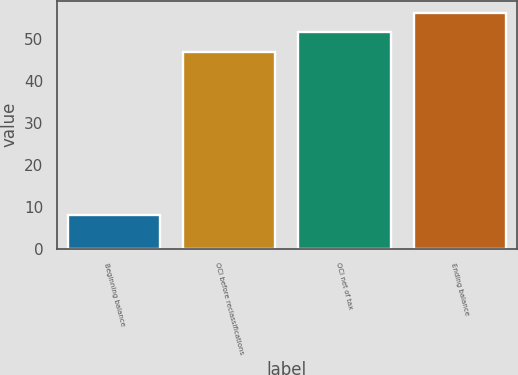Convert chart to OTSL. <chart><loc_0><loc_0><loc_500><loc_500><bar_chart><fcel>Beginning balance<fcel>OCI before reclassifications<fcel>OCI net of tax<fcel>Ending balance<nl><fcel>8<fcel>47<fcel>51.7<fcel>56.4<nl></chart> 